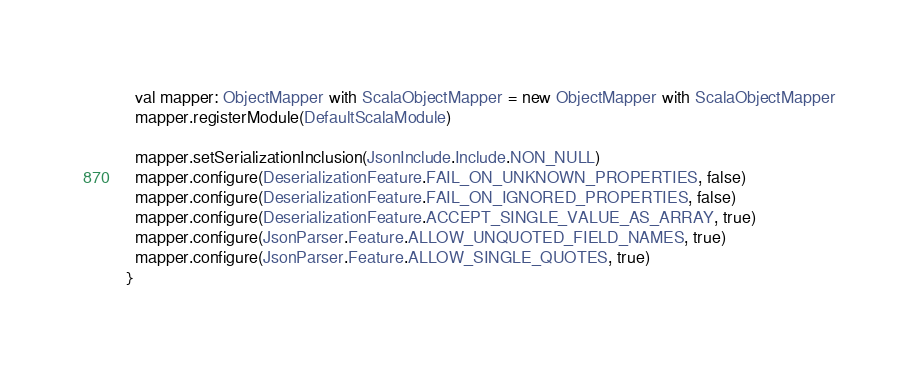Convert code to text. <code><loc_0><loc_0><loc_500><loc_500><_Scala_>
  val mapper: ObjectMapper with ScalaObjectMapper = new ObjectMapper with ScalaObjectMapper
  mapper.registerModule(DefaultScalaModule)

  mapper.setSerializationInclusion(JsonInclude.Include.NON_NULL)
  mapper.configure(DeserializationFeature.FAIL_ON_UNKNOWN_PROPERTIES, false)
  mapper.configure(DeserializationFeature.FAIL_ON_IGNORED_PROPERTIES, false)
  mapper.configure(DeserializationFeature.ACCEPT_SINGLE_VALUE_AS_ARRAY, true)
  mapper.configure(JsonParser.Feature.ALLOW_UNQUOTED_FIELD_NAMES, true)
  mapper.configure(JsonParser.Feature.ALLOW_SINGLE_QUOTES, true)
}
</code> 